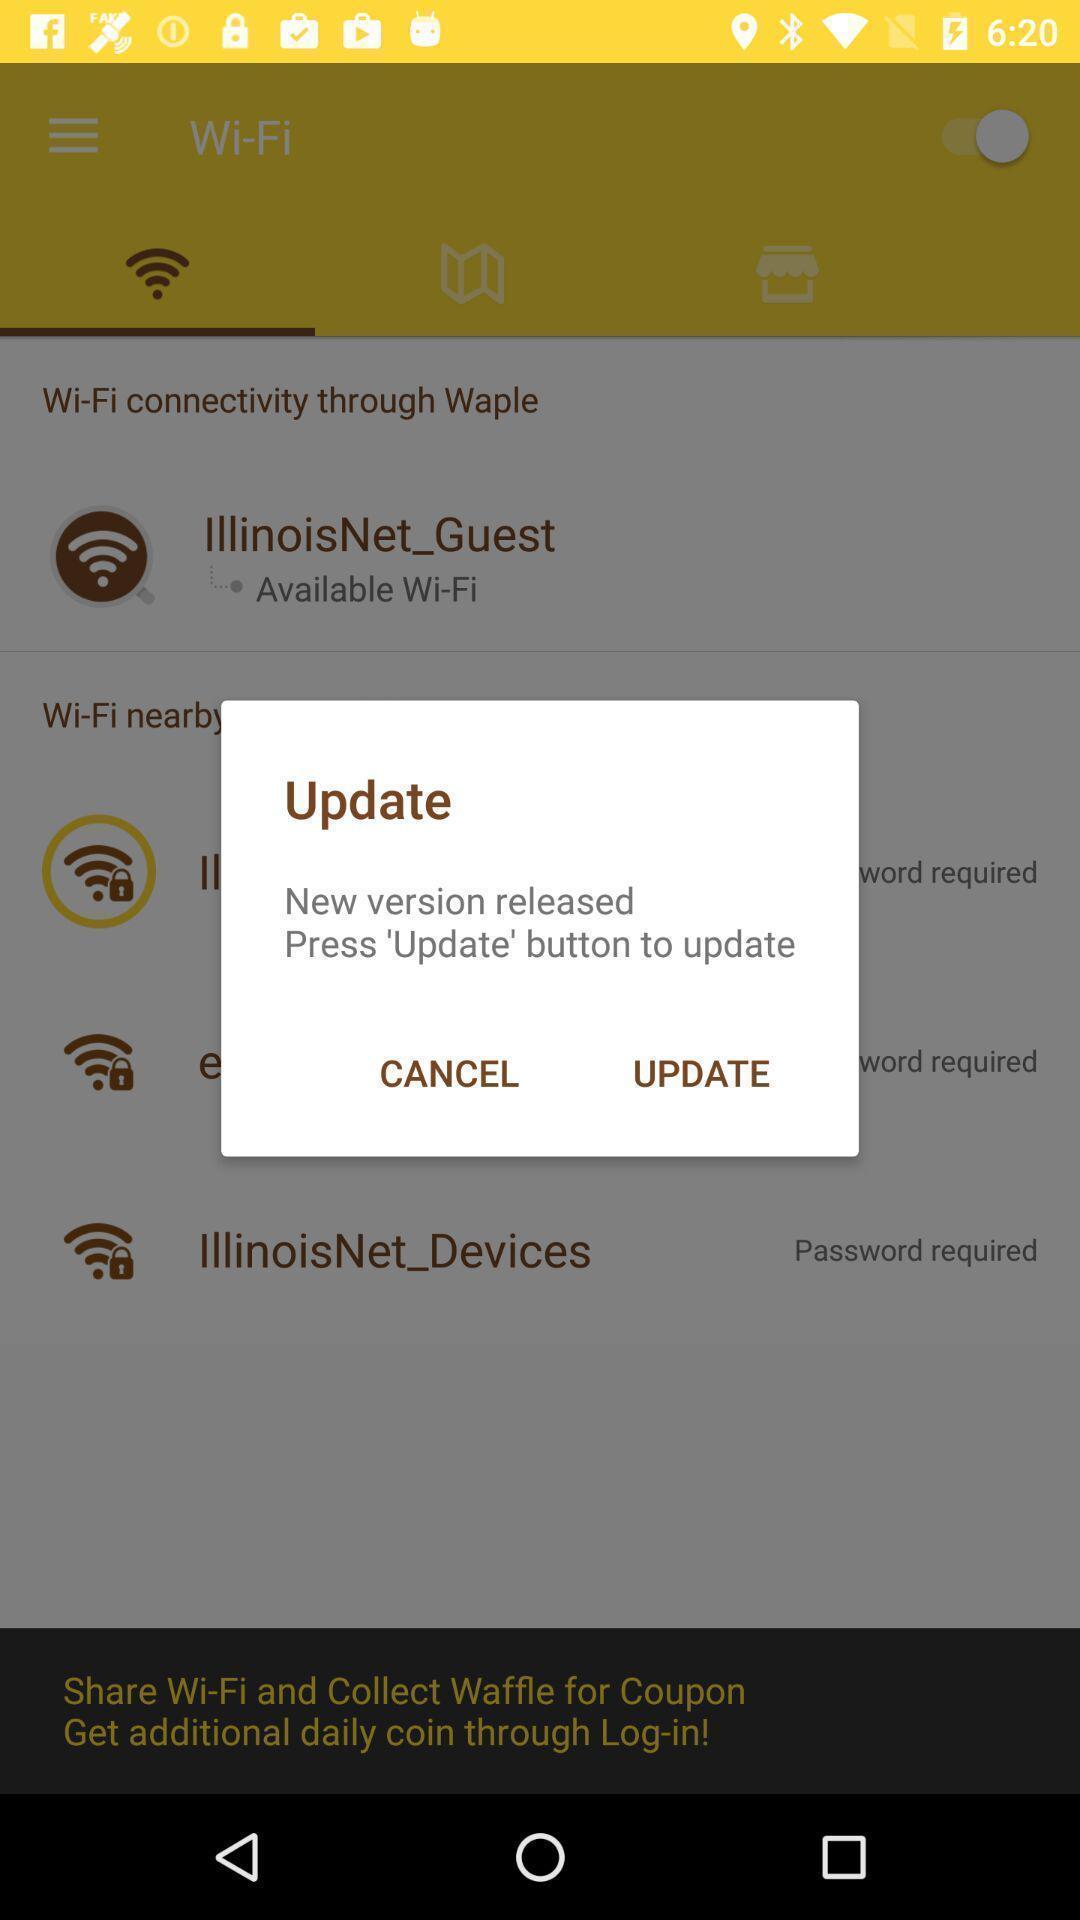Provide a textual representation of this image. Update pop up of wifi hotspots page. 